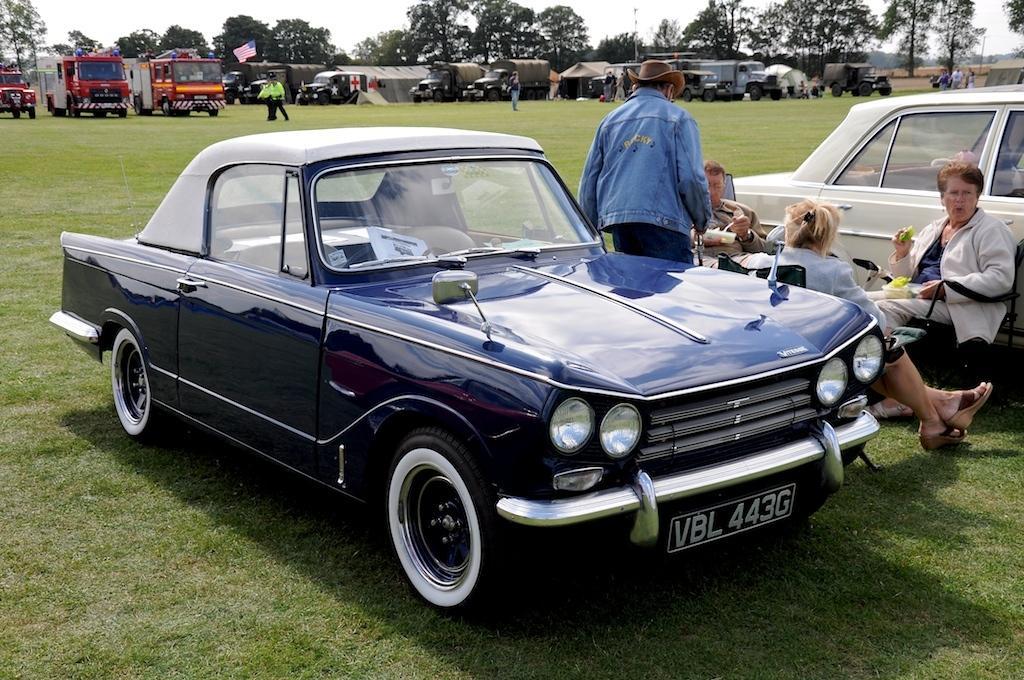Please provide a concise description of this image. In this image, we can see vehicles and there are people and some of them are wearing coats and caps and some are sitting on the chairs and holding some objects. In the background, there are trees and we can see poles and a flag. At the top, there is sky. 